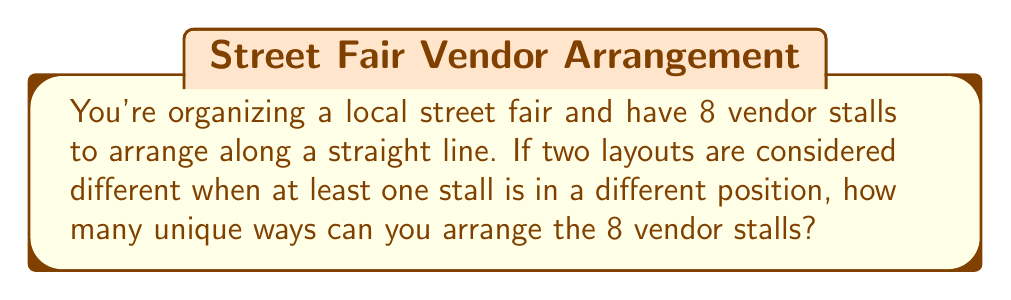Teach me how to tackle this problem. Let's approach this step-by-step:

1) This is a permutation problem. We need to arrange 8 distinct objects (vendor stalls) in a line.

2) For the first position, we have 8 choices of stalls to place.

3) For the second position, we now have 7 remaining stalls to choose from.

4) For the third position, we have 6 stalls left, and so on.

5) This continues until we place the last stall, for which we'll have only 1 choice left.

6) The total number of ways to arrange these stalls is the product of all these choices:

   $$ 8 \times 7 \times 6 \times 5 \times 4 \times 3 \times 2 \times 1 $$

7) This is the definition of 8 factorial, written as 8!

8) Calculate:
   $$ 8! = 8 \times 7 \times 6 \times 5 \times 4 \times 3 \times 2 \times 1 = 40,320 $$

Therefore, there are 40,320 unique ways to arrange the 8 vendor stalls.
Answer: $40,320$ 